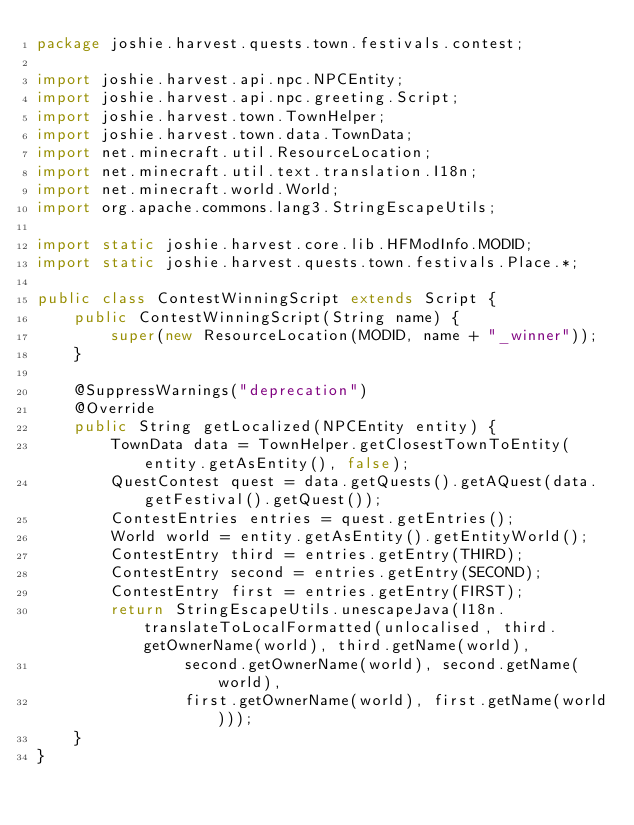Convert code to text. <code><loc_0><loc_0><loc_500><loc_500><_Java_>package joshie.harvest.quests.town.festivals.contest;

import joshie.harvest.api.npc.NPCEntity;
import joshie.harvest.api.npc.greeting.Script;
import joshie.harvest.town.TownHelper;
import joshie.harvest.town.data.TownData;
import net.minecraft.util.ResourceLocation;
import net.minecraft.util.text.translation.I18n;
import net.minecraft.world.World;
import org.apache.commons.lang3.StringEscapeUtils;

import static joshie.harvest.core.lib.HFModInfo.MODID;
import static joshie.harvest.quests.town.festivals.Place.*;

public class ContestWinningScript extends Script {
    public ContestWinningScript(String name) {
        super(new ResourceLocation(MODID, name + "_winner"));
    }

    @SuppressWarnings("deprecation")
    @Override
    public String getLocalized(NPCEntity entity) {
        TownData data = TownHelper.getClosestTownToEntity(entity.getAsEntity(), false);
        QuestContest quest = data.getQuests().getAQuest(data.getFestival().getQuest());
        ContestEntries entries = quest.getEntries();
        World world = entity.getAsEntity().getEntityWorld();
        ContestEntry third = entries.getEntry(THIRD);
        ContestEntry second = entries.getEntry(SECOND);
        ContestEntry first = entries.getEntry(FIRST);
        return StringEscapeUtils.unescapeJava(I18n.translateToLocalFormatted(unlocalised, third.getOwnerName(world), third.getName(world),
                second.getOwnerName(world), second.getName(world),
                first.getOwnerName(world), first.getName(world)));
    }
}
</code> 